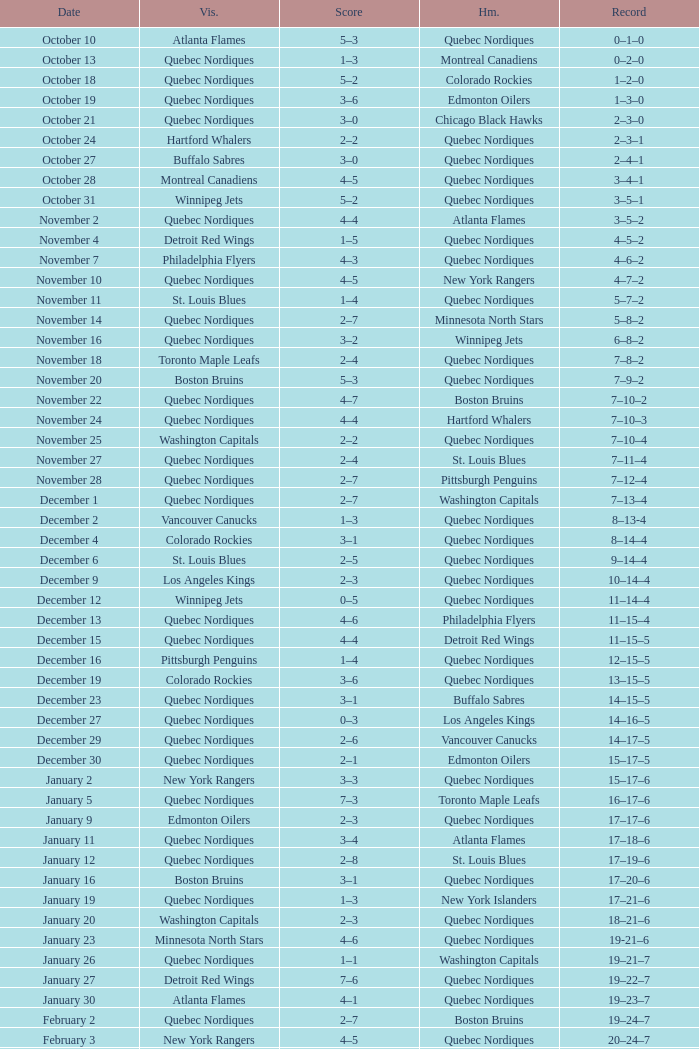Which Record has a Home of edmonton oilers, and a Score of 3–6? 1–3–0. 